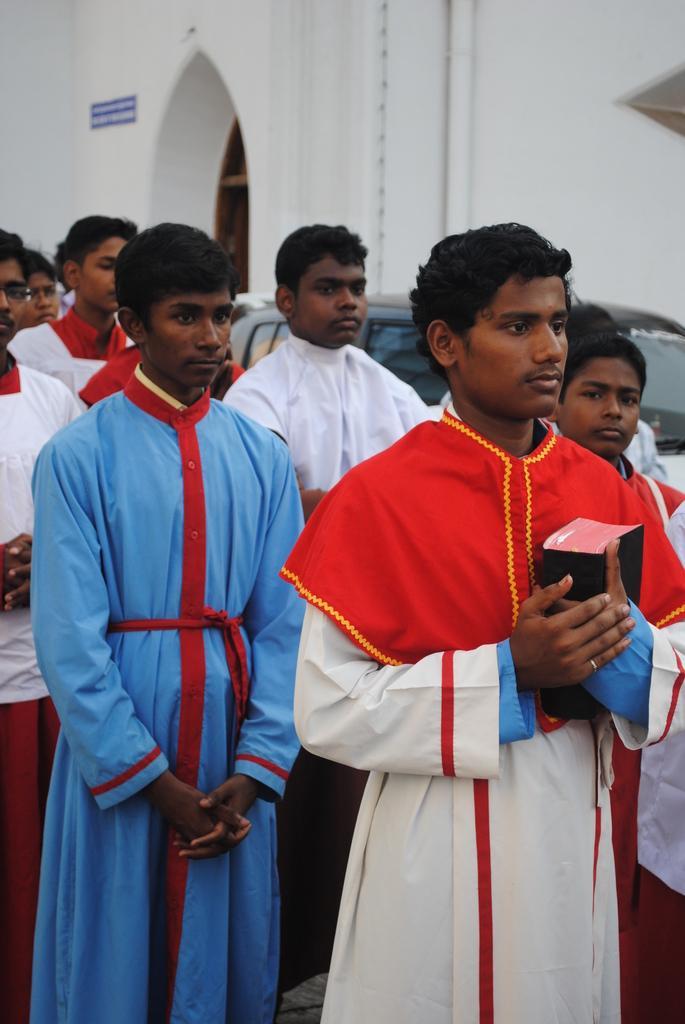Describe this image in one or two sentences. In this picture there is a person standing and holding the book and there are group of people standing. At the back there is a vehicle and there is a building and there is a board and pipe on the wall. 